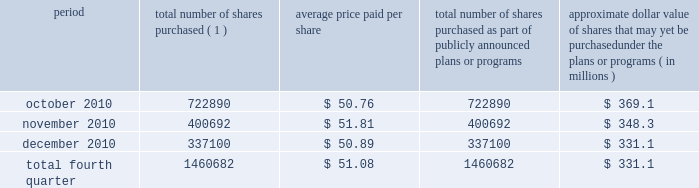Issuer purchases of equity securities during the three months ended december 31 , 2010 , we repurchased 1460682 shares of our common stock for an aggregate of $ 74.6 million , including commissions and fees , pursuant to our publicly announced stock repurchase program , as follows : period total number of shares purchased ( 1 ) average price paid per share total number of shares purchased as part of publicly announced plans or programs approximate dollar value of shares that may yet be purchased under the plans or programs ( in millions ) .
( 1 ) repurchases made pursuant to the $ 1.5 billion stock repurchase program approved by our board of directors in february 2008 ( the 201cbuyback 201d ) .
Under this program , our management is authorized to purchase shares from time to time through open market purchases or privately negotiated transactions at prevailing prices as permitted by securities laws and other legal requirements , and subject to market conditions and other factors .
To facilitate repurchases , we make purchases pursuant to trading plans under rule 10b5-1 of the exchange act , which allows us to repurchase shares during periods when we otherwise might be prevented from doing so under insider trading laws or because of self-imposed trading blackout periods .
This program may be discontinued at any time .
Subsequent to december 31 , 2010 , we repurchased 1122481 shares of our common stock for an aggregate of $ 58.0 million , including commissions and fees , pursuant to the buyback .
As of february 11 , 2011 , we had repurchased a total of 30.9 million shares of our common stock for an aggregate of $ 1.2 billion , including commissions and fees pursuant to the buyback .
We expect to continue to manage the pacing of the remaining $ 273.1 million under the buyback in response to general market conditions and other relevant factors. .
What portion of total shares repurchased in the fourth quarter of 2010 occurred during october? 
Computations: (722890 / 1460682)
Answer: 0.4949. 